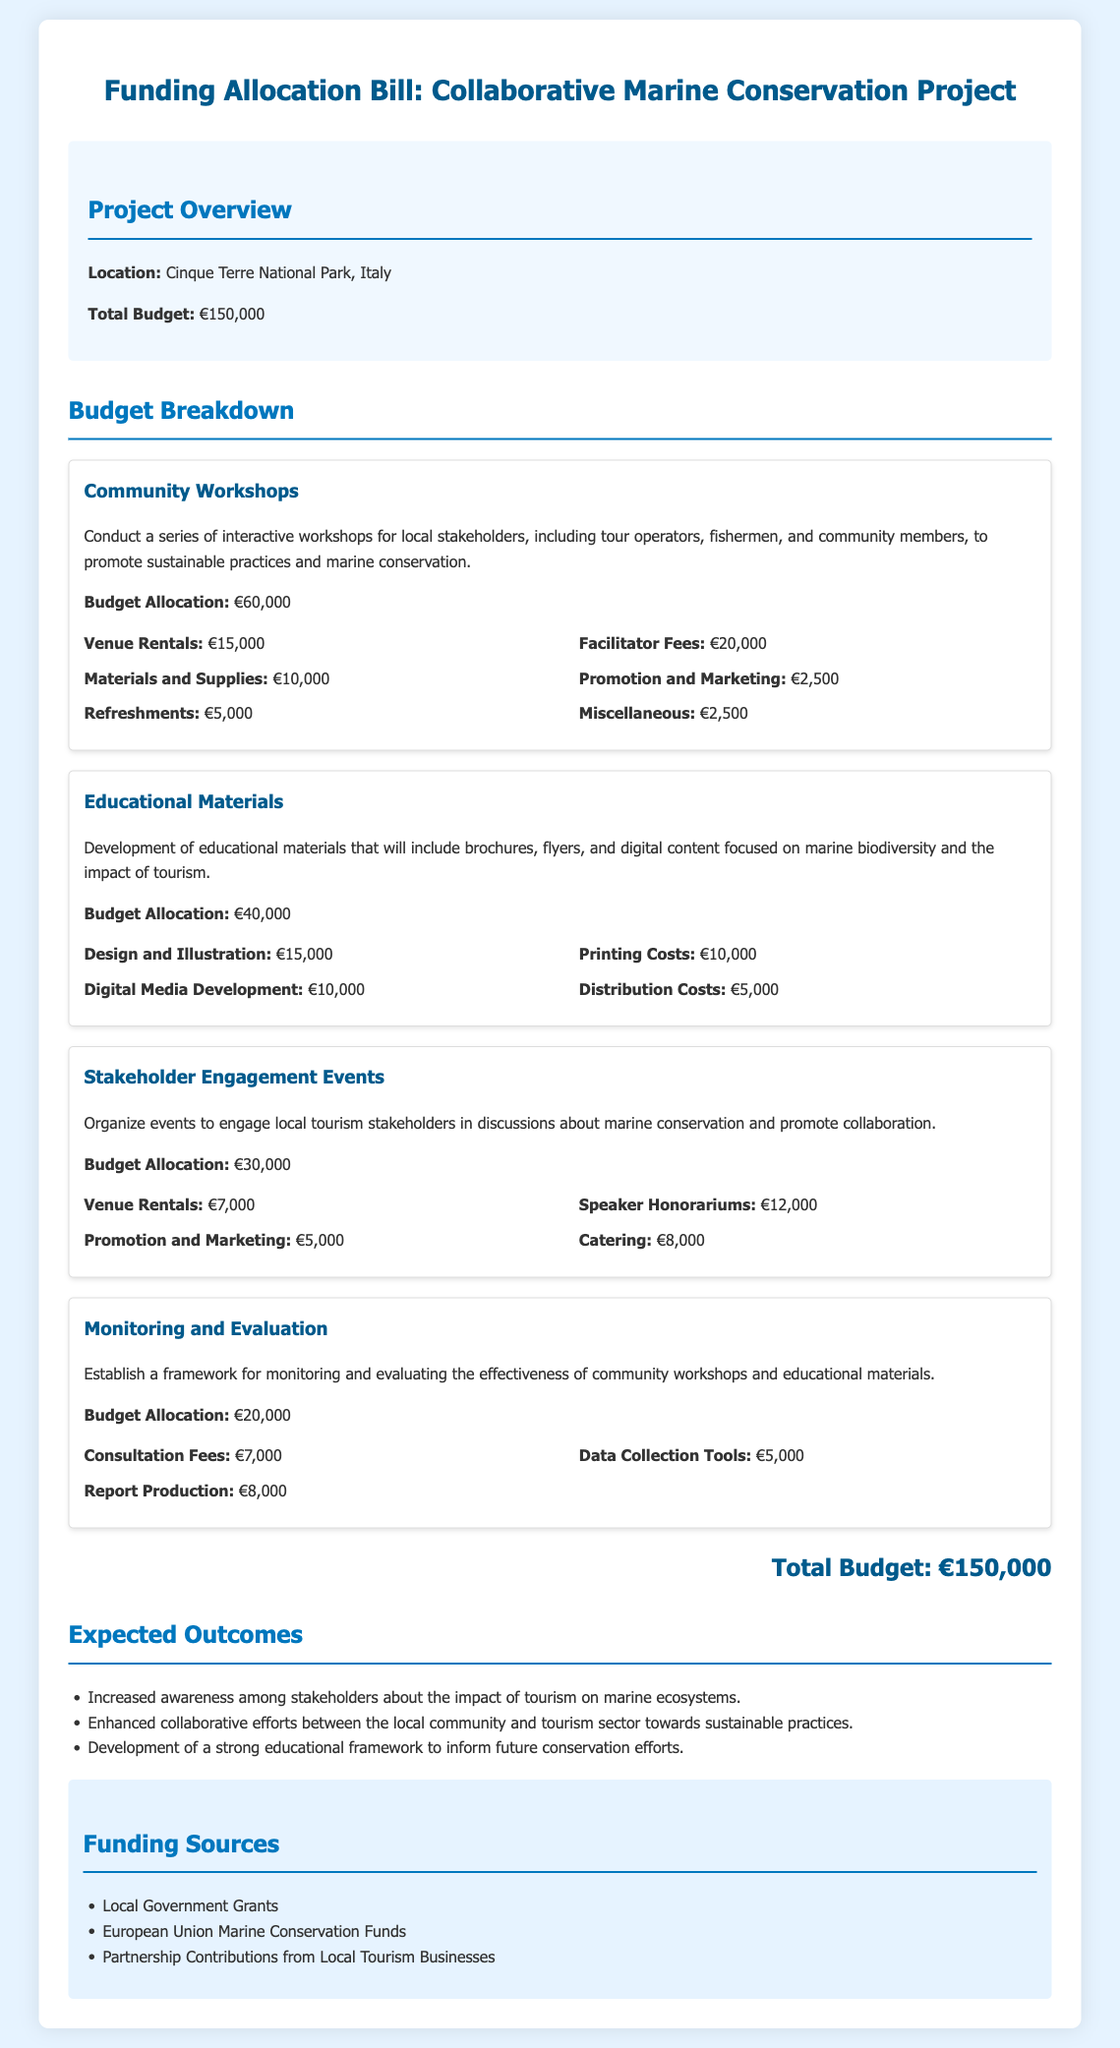What is the total budget? The total budget is specified in the project overview section of the document.
Answer: €150,000 How much is allocated for community workshops? The budget allocation for community workshops is detailed under the respective budget section.
Answer: €60,000 What are the total costs for educational materials? The budget allocation for educational materials is listed in the budget breakdown.
Answer: €40,000 What is the funding source mentioned in the document? The document lists several funding sources, which is a unique aspect of this bill.
Answer: Local Government Grants What is the budget allocation for monitoring and evaluation? The budget section specifies the allocation for monitoring and evaluation.
Answer: €20,000 How much is allocated for design and illustration in educational materials? The specific cost for design and illustration is found in the educational materials section.
Answer: €15,000 What is the purpose of stakeholder engagement events? The document explains the aim of organizing events within the corresponding budget section.
Answer: Engage local tourism stakeholders How much is budgeted for catering at stakeholder engagement events? The costs related to catering can be found in the budget breakdown for stakeholder events.
Answer: €8,000 What are the expected outcomes from this project? The expected outcomes are listed in the outcomes section of the document.
Answer: Increased awareness among stakeholders 